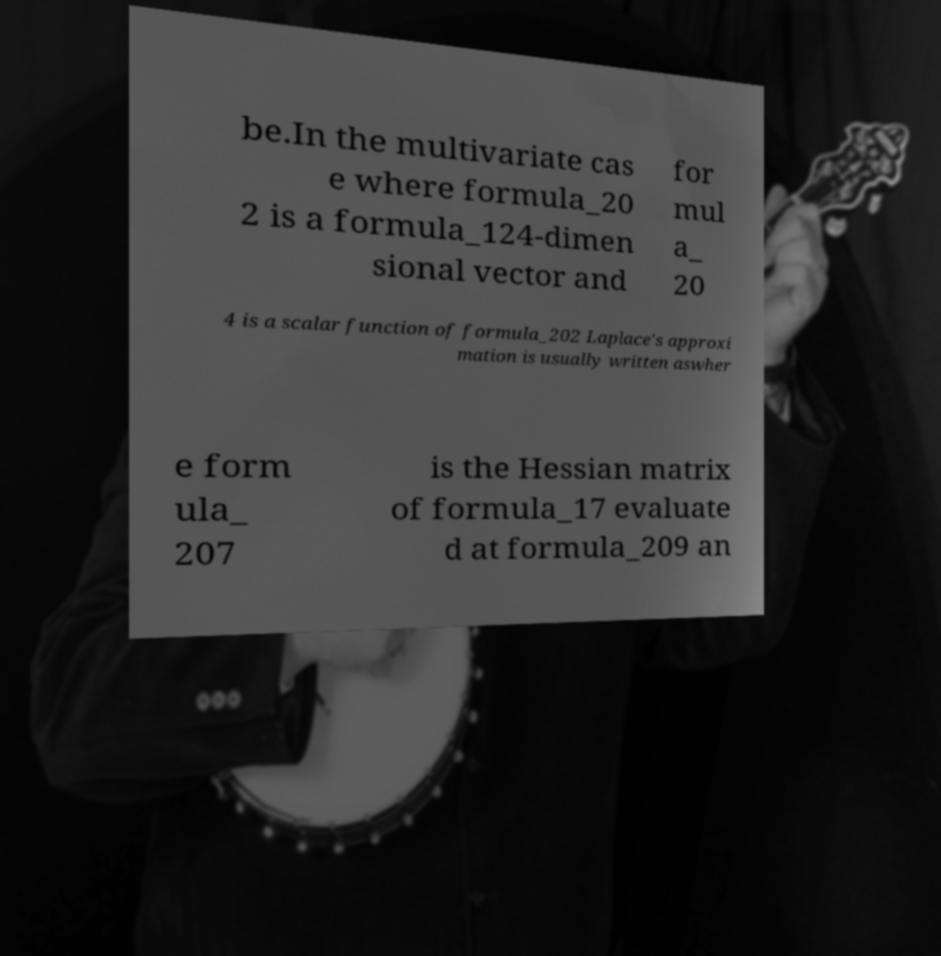Please identify and transcribe the text found in this image. be.In the multivariate cas e where formula_20 2 is a formula_124-dimen sional vector and for mul a_ 20 4 is a scalar function of formula_202 Laplace's approxi mation is usually written aswher e form ula_ 207 is the Hessian matrix of formula_17 evaluate d at formula_209 an 